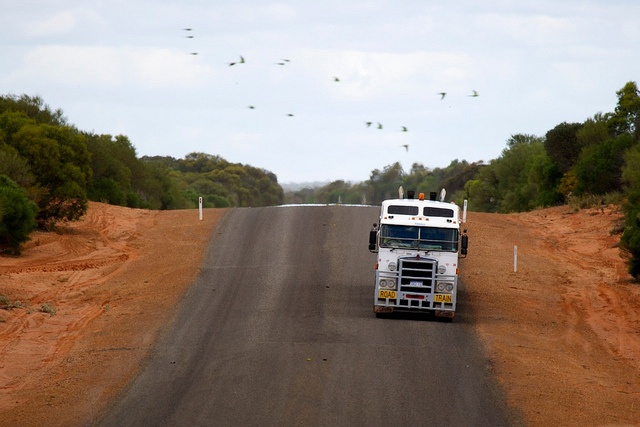Describe the objects in this image and their specific colors. I can see truck in lavender, black, lightgray, gray, and darkgray tones, bird in lavender, darkgray, lightgray, and gray tones, bird in lavender, lightgray, and darkgray tones, bird in lavender, lightgray, darkgray, and olive tones, and bird in lavender, lightgray, darkgray, and olive tones in this image. 